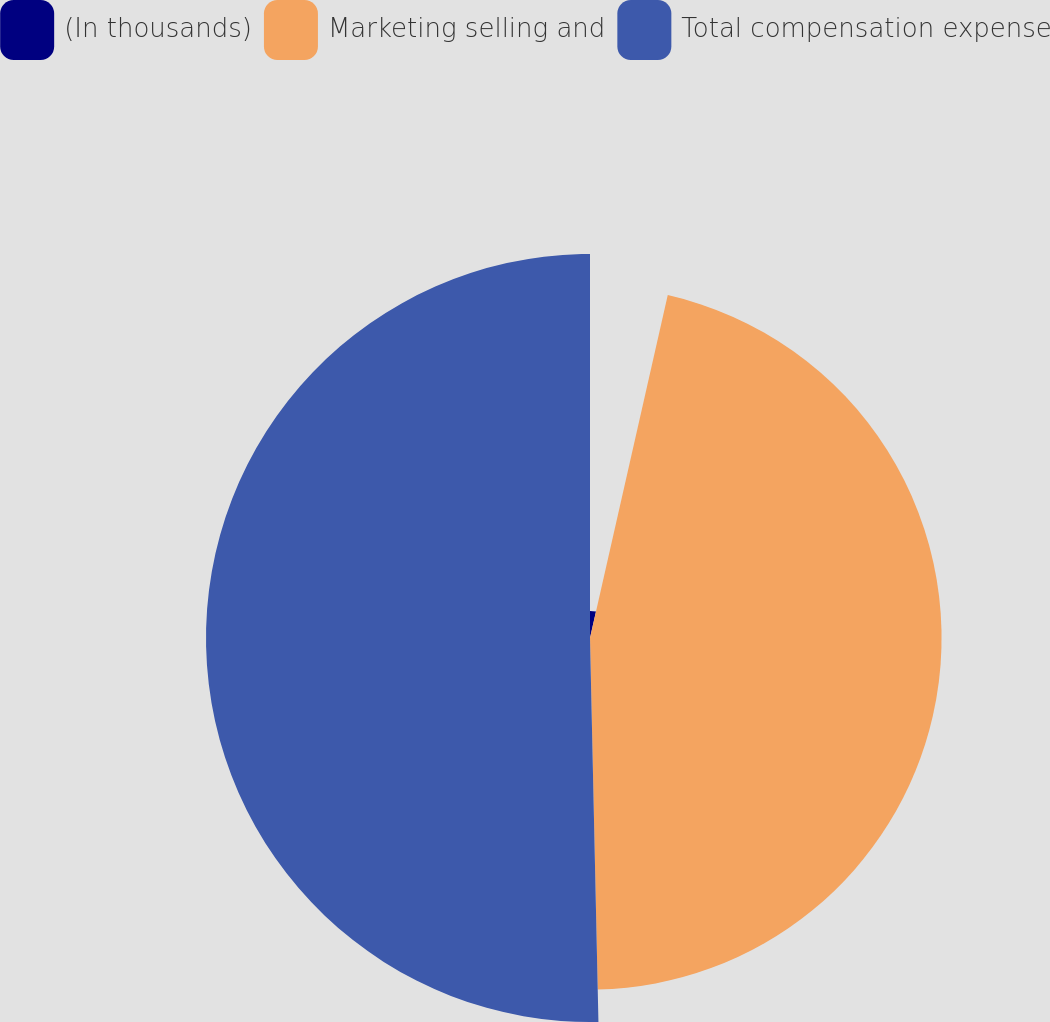Convert chart to OTSL. <chart><loc_0><loc_0><loc_500><loc_500><pie_chart><fcel>(In thousands)<fcel>Marketing selling and<fcel>Total compensation expense<nl><fcel>3.55%<fcel>46.1%<fcel>50.35%<nl></chart> 